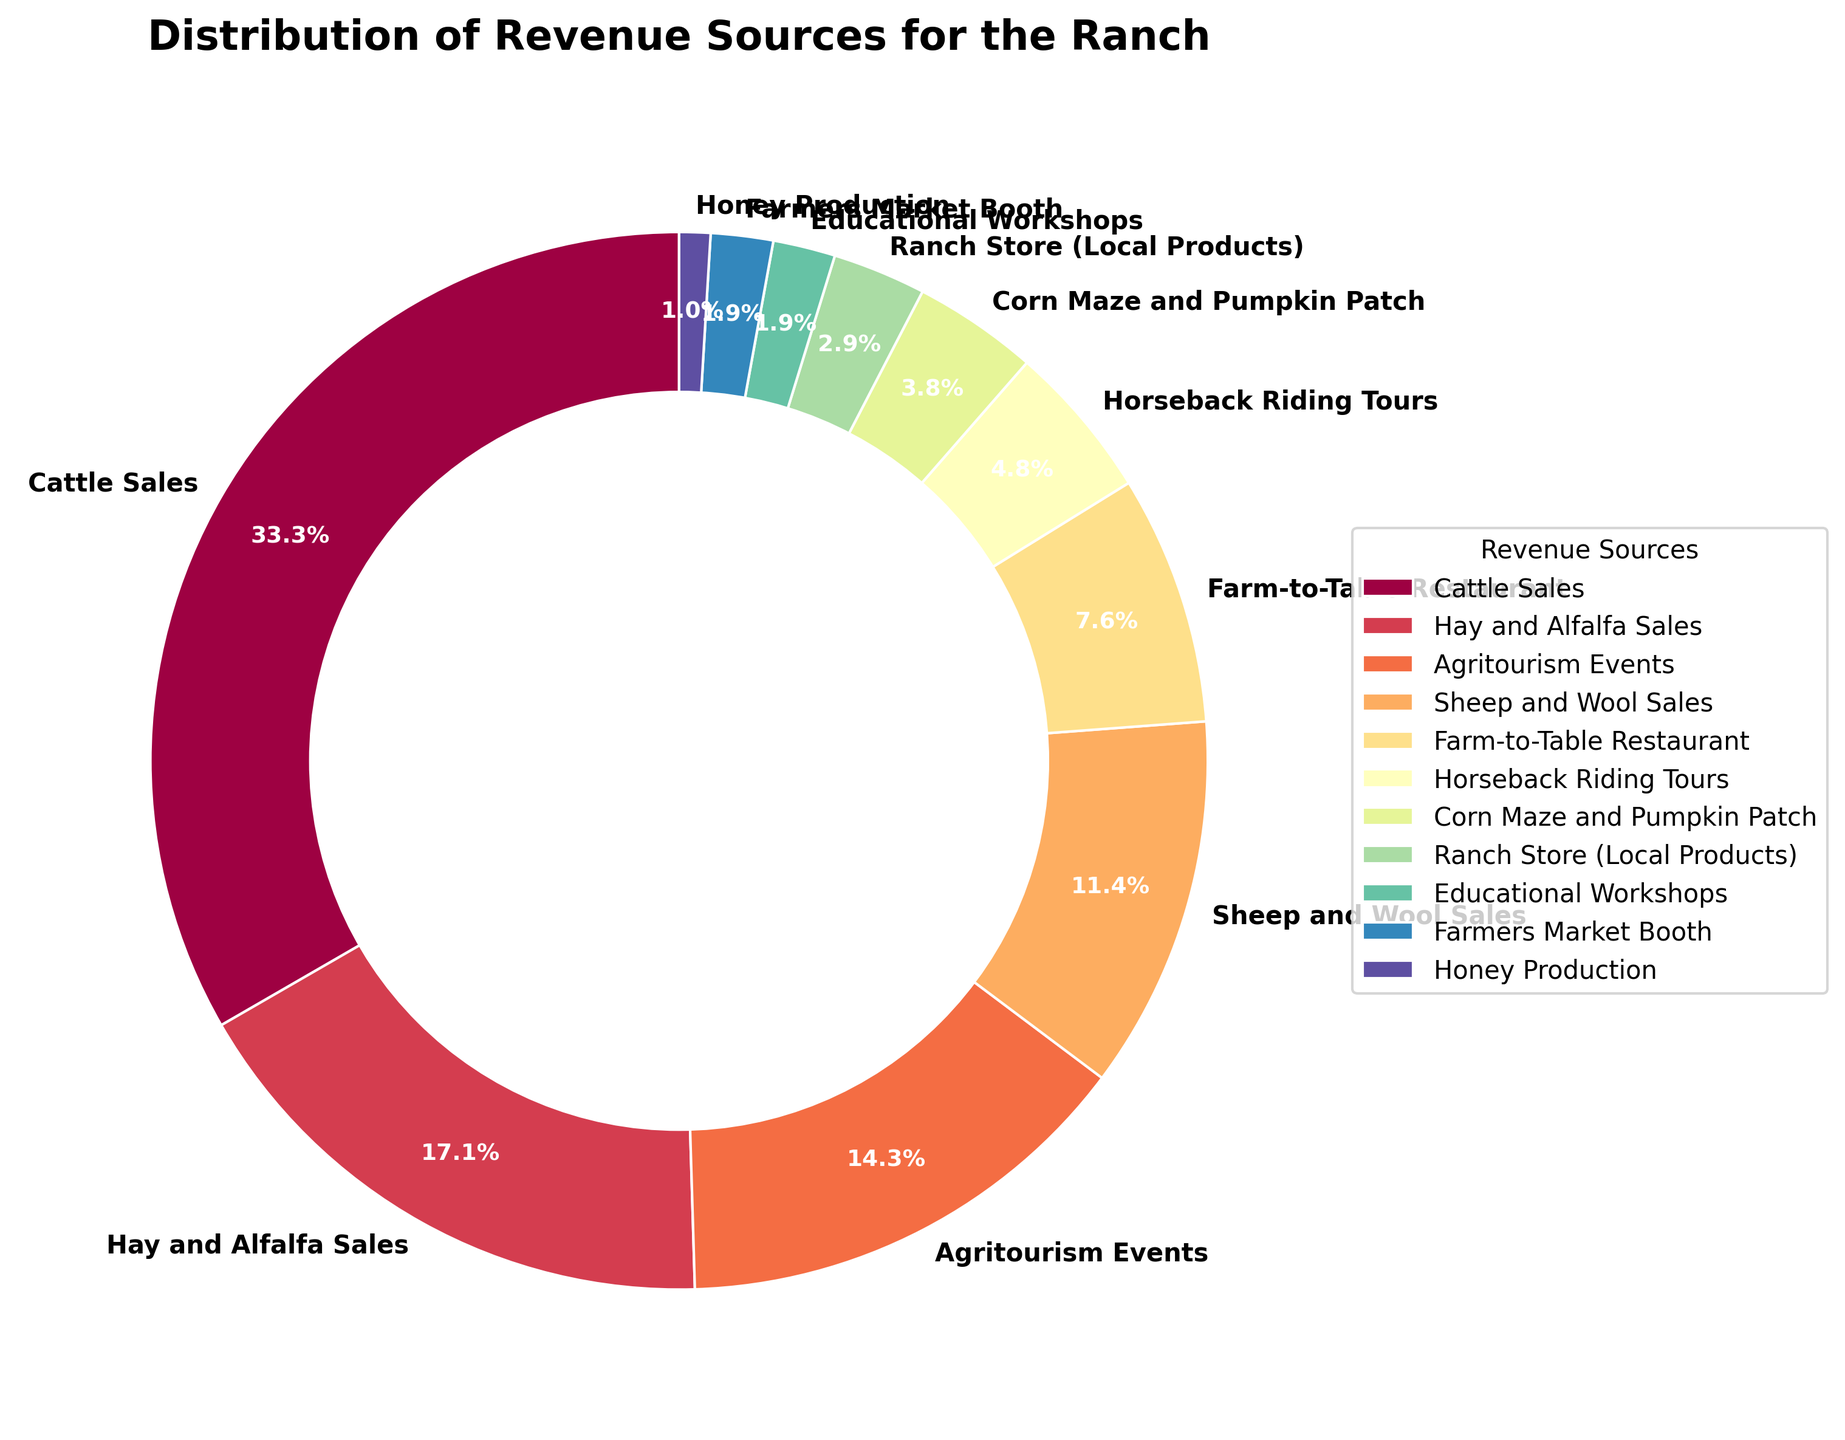What is the largest single source of revenue for the ranch? By looking at the pie chart, the segment that occupies the largest area represents the largest source of revenue. The label for that segment is "Cattle Sales" with 35%.
Answer: Cattle Sales What is the total percentage of revenue coming from livestock-related sales (Cattle, Sheep, Wool)? Identify the segments for Cattle Sales (35%) and Sheep and Wool Sales (12%) and sum their percentages: 35 + 12 = 47%.
Answer: 47% Which is larger: revenue from Agritourism Events or Farm-to-Table Restaurant? Find the two segments representing Agritourism Events (15%) and Farm-to-Table Restaurant (8%) and compare their percentages. 15% is larger than 8%.
Answer: Agritourism Events What percentage of revenue comes from activities other than livestock (non-livestock revenue)? Subtract the total percentage of livestock-related revenue (47%) from 100%: 100 - 47 = 53%.
Answer: 53% What is the combined percentage of revenue from Horseback Riding Tours and Corn Maze and Pumpkin Patch? Add the percentages for Horseback Riding Tours (5%) and Corn Maze and Pumpkin Patch (4%): 5 + 4 = 9%.
Answer: 9% Which source of revenue is depicted in the smallest segment, and what is its percentage? Identify the smallest segment in the pie chart, which is labeled "Honey Production" with 1%.
Answer: Honey Production, 1% Is the revenue from Hay and Alfalfa Sales greater or less than the revenue from all Educational Workshops and Farmers Market Booth combined? Compare Hay and Alfalfa Sales (18%) with the combined total of Educational Workshops (2%) and Farmers Market Booth (2%): 18% is greater than 2% + 2% = 4%.
Answer: Greater How does the percentage of revenue from Ranch Store (Local Products) compare to from Educational Workshops? Compare the percentages for Ranch Store (Local Products) (3%) and Educational Workshops (2%): 3% is greater than 2%.
Answer: Greater What proportion of revenue is generated by agritourism activities (sum of Agritourism Events, Horseback Riding Tours, and Corn Maze and Pumpkin Patch)? Add the percentages for Agritourism Events (15%), Horseback Riding Tours (5%), and Corn Maze and Pumpkin Patch (4%): 15 + 5 + 4 = 24%.
Answer: 24% What is the difference in percentage between revenue from Cattle Sales and Hay and Alfalfa Sales? Subtract the percentage of Hay and Alfalfa Sales (18%) from Cattle Sales (35%): 35 - 18 = 17%.
Answer: 17% 